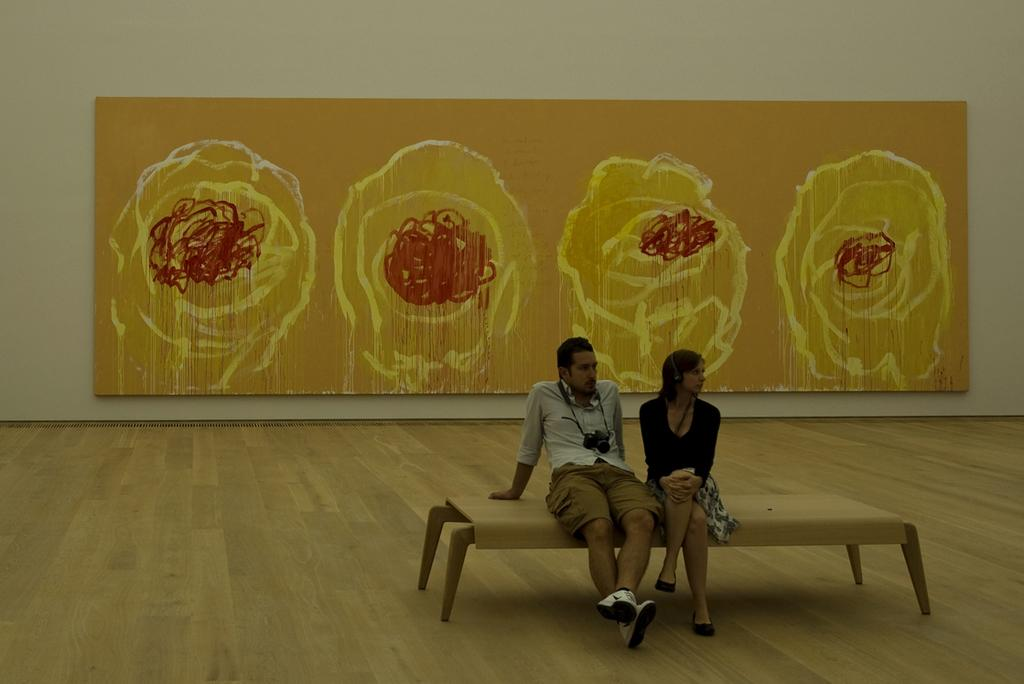Who are the people in the image? There is a man and a woman in the image. What are the man and woman doing in the image? The man and woman are sitting on a bench. What accessories are the man and woman wearing in the image? The man is wearing a camera, and the woman is wearing headphones. What can be seen in the background of the image? There is a wall in the background of the image, and there is a painting on the wall. What type of paper is the man using to take pictures in the image? The man is not using paper to take pictures in the image; he is wearing a camera. How many nuts are visible on the bench in the image? There are no nuts visible on the bench in the image. 